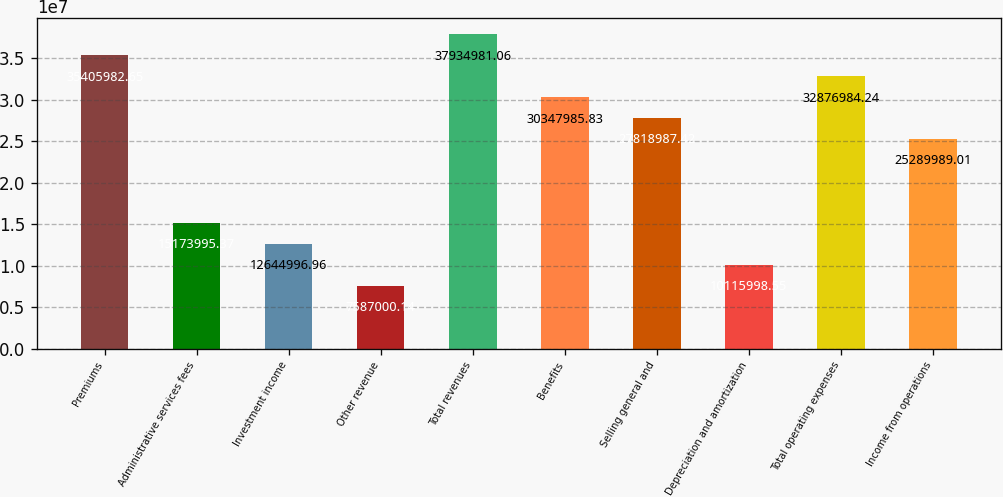<chart> <loc_0><loc_0><loc_500><loc_500><bar_chart><fcel>Premiums<fcel>Administrative services fees<fcel>Investment income<fcel>Other revenue<fcel>Total revenues<fcel>Benefits<fcel>Selling general and<fcel>Depreciation and amortization<fcel>Total operating expenses<fcel>Income from operations<nl><fcel>3.5406e+07<fcel>1.5174e+07<fcel>1.2645e+07<fcel>7.587e+06<fcel>3.7935e+07<fcel>3.0348e+07<fcel>2.7819e+07<fcel>1.0116e+07<fcel>3.2877e+07<fcel>2.529e+07<nl></chart> 